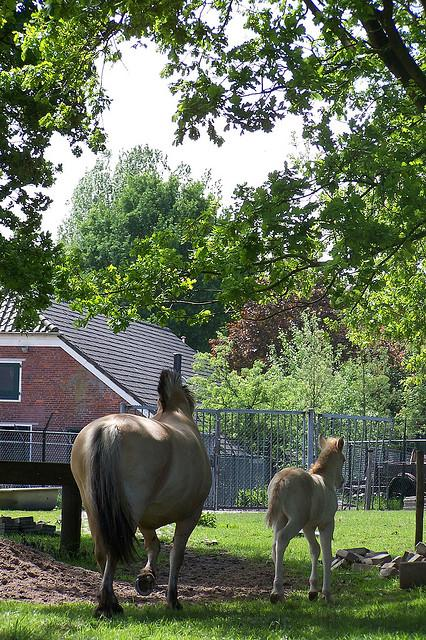What are the horses doing? walking 